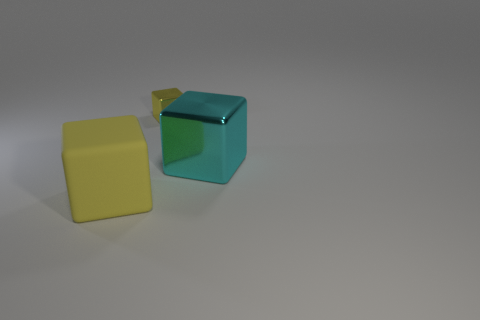Are any gray things visible?
Offer a terse response. No. What size is the other cube that is the same material as the tiny yellow block?
Keep it short and to the point. Large. Is the cyan thing made of the same material as the tiny thing?
Provide a short and direct response. Yes. How many other objects are there of the same material as the big yellow cube?
Your answer should be very brief. 0. What number of yellow objects are both to the left of the tiny shiny thing and to the right of the big yellow rubber thing?
Provide a succinct answer. 0. The big shiny object has what color?
Provide a short and direct response. Cyan. What material is the other large yellow object that is the same shape as the large shiny object?
Keep it short and to the point. Rubber. Is there anything else that is the same material as the big yellow object?
Your response must be concise. No. Is the color of the small shiny thing the same as the rubber block?
Ensure brevity in your answer.  Yes. There is a thing that is behind the large cyan metallic object that is to the right of the small metal thing; what is its shape?
Give a very brief answer. Cube. 